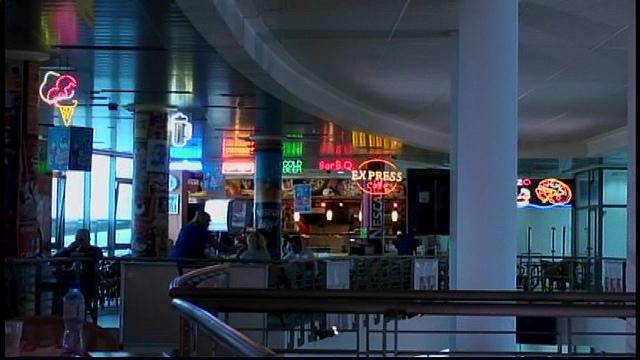Are there customers sitting at the counter?
Quick response, please. Yes. Could this be inside of a church?
Answer briefly. No. Is this a bar?
Short answer required. Yes. Why is this area dimly lit?
Keep it brief. Yes. Are these people waiters for this food court?
Give a very brief answer. No. 